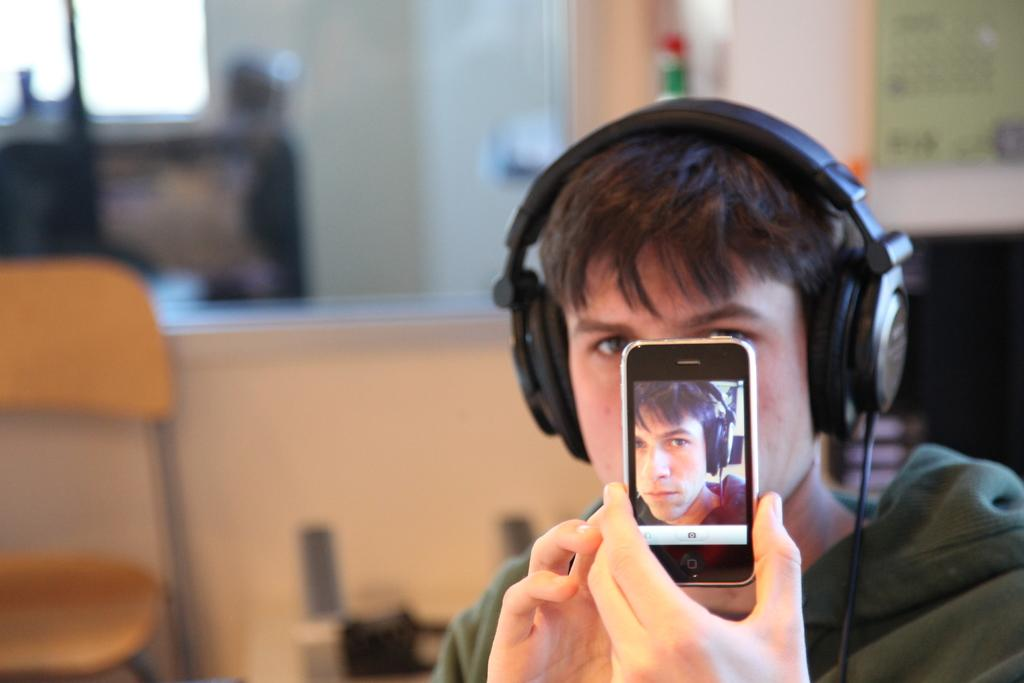Who is present in the image? There is a man in the image. What is the man holding in the image? The man is holding a phone. What can be seen in the background of the image? There is a chair in the background of the image. What type of yam is the man eating in the image? There is no yam present in the image; the man is holding a phone. 